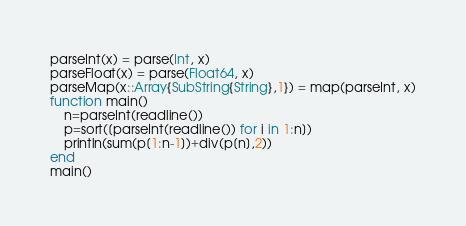Convert code to text. <code><loc_0><loc_0><loc_500><loc_500><_Julia_>parseInt(x) = parse(Int, x)
parseFloat(x) = parse(Float64, x)
parseMap(x::Array{SubString{String},1}) = map(parseInt, x)
function main()
    n=parseInt(readline())
    p=sort([parseInt(readline()) for i in 1:n])
    println(sum(p[1:n-1])+div(p[n],2))
end
main()</code> 